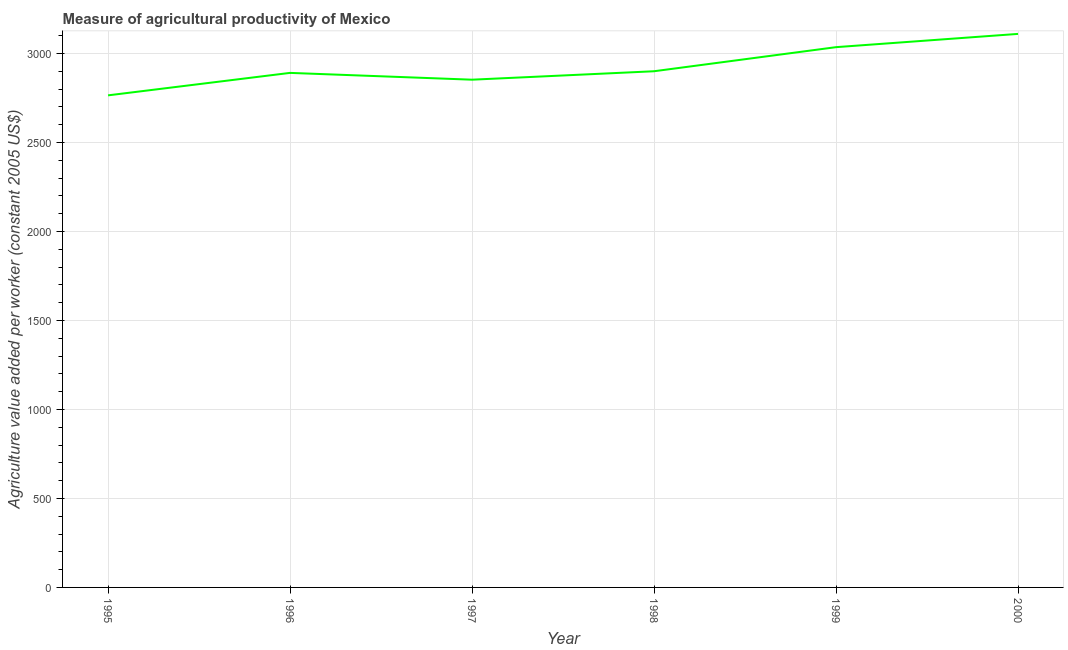What is the agriculture value added per worker in 1996?
Offer a very short reply. 2891.52. Across all years, what is the maximum agriculture value added per worker?
Ensure brevity in your answer.  3110.61. Across all years, what is the minimum agriculture value added per worker?
Provide a succinct answer. 2765.24. In which year was the agriculture value added per worker maximum?
Keep it short and to the point. 2000. In which year was the agriculture value added per worker minimum?
Provide a short and direct response. 1995. What is the sum of the agriculture value added per worker?
Provide a succinct answer. 1.76e+04. What is the difference between the agriculture value added per worker in 1997 and 2000?
Give a very brief answer. -257.34. What is the average agriculture value added per worker per year?
Make the answer very short. 2926.24. What is the median agriculture value added per worker?
Ensure brevity in your answer.  2896.13. In how many years, is the agriculture value added per worker greater than 2400 US$?
Keep it short and to the point. 6. What is the ratio of the agriculture value added per worker in 1995 to that in 1998?
Offer a terse response. 0.95. Is the agriculture value added per worker in 1999 less than that in 2000?
Provide a short and direct response. Yes. Is the difference between the agriculture value added per worker in 1998 and 1999 greater than the difference between any two years?
Make the answer very short. No. What is the difference between the highest and the second highest agriculture value added per worker?
Ensure brevity in your answer.  74.53. Is the sum of the agriculture value added per worker in 1995 and 1997 greater than the maximum agriculture value added per worker across all years?
Make the answer very short. Yes. What is the difference between the highest and the lowest agriculture value added per worker?
Your response must be concise. 345.37. In how many years, is the agriculture value added per worker greater than the average agriculture value added per worker taken over all years?
Offer a very short reply. 2. How many lines are there?
Your response must be concise. 1. Does the graph contain any zero values?
Keep it short and to the point. No. What is the title of the graph?
Provide a succinct answer. Measure of agricultural productivity of Mexico. What is the label or title of the X-axis?
Make the answer very short. Year. What is the label or title of the Y-axis?
Offer a very short reply. Agriculture value added per worker (constant 2005 US$). What is the Agriculture value added per worker (constant 2005 US$) of 1995?
Give a very brief answer. 2765.24. What is the Agriculture value added per worker (constant 2005 US$) of 1996?
Provide a short and direct response. 2891.52. What is the Agriculture value added per worker (constant 2005 US$) in 1997?
Your answer should be compact. 2853.27. What is the Agriculture value added per worker (constant 2005 US$) in 1998?
Ensure brevity in your answer.  2900.74. What is the Agriculture value added per worker (constant 2005 US$) in 1999?
Your response must be concise. 3036.08. What is the Agriculture value added per worker (constant 2005 US$) of 2000?
Your answer should be very brief. 3110.61. What is the difference between the Agriculture value added per worker (constant 2005 US$) in 1995 and 1996?
Provide a short and direct response. -126.28. What is the difference between the Agriculture value added per worker (constant 2005 US$) in 1995 and 1997?
Provide a succinct answer. -88.03. What is the difference between the Agriculture value added per worker (constant 2005 US$) in 1995 and 1998?
Provide a succinct answer. -135.5. What is the difference between the Agriculture value added per worker (constant 2005 US$) in 1995 and 1999?
Offer a terse response. -270.84. What is the difference between the Agriculture value added per worker (constant 2005 US$) in 1995 and 2000?
Provide a succinct answer. -345.37. What is the difference between the Agriculture value added per worker (constant 2005 US$) in 1996 and 1997?
Ensure brevity in your answer.  38.25. What is the difference between the Agriculture value added per worker (constant 2005 US$) in 1996 and 1998?
Your answer should be compact. -9.22. What is the difference between the Agriculture value added per worker (constant 2005 US$) in 1996 and 1999?
Provide a succinct answer. -144.56. What is the difference between the Agriculture value added per worker (constant 2005 US$) in 1996 and 2000?
Offer a terse response. -219.09. What is the difference between the Agriculture value added per worker (constant 2005 US$) in 1997 and 1998?
Provide a short and direct response. -47.47. What is the difference between the Agriculture value added per worker (constant 2005 US$) in 1997 and 1999?
Offer a very short reply. -182.81. What is the difference between the Agriculture value added per worker (constant 2005 US$) in 1997 and 2000?
Give a very brief answer. -257.34. What is the difference between the Agriculture value added per worker (constant 2005 US$) in 1998 and 1999?
Your answer should be compact. -135.34. What is the difference between the Agriculture value added per worker (constant 2005 US$) in 1998 and 2000?
Make the answer very short. -209.87. What is the difference between the Agriculture value added per worker (constant 2005 US$) in 1999 and 2000?
Give a very brief answer. -74.53. What is the ratio of the Agriculture value added per worker (constant 2005 US$) in 1995 to that in 1996?
Your answer should be very brief. 0.96. What is the ratio of the Agriculture value added per worker (constant 2005 US$) in 1995 to that in 1998?
Your answer should be very brief. 0.95. What is the ratio of the Agriculture value added per worker (constant 2005 US$) in 1995 to that in 1999?
Provide a succinct answer. 0.91. What is the ratio of the Agriculture value added per worker (constant 2005 US$) in 1995 to that in 2000?
Your answer should be compact. 0.89. What is the ratio of the Agriculture value added per worker (constant 2005 US$) in 1996 to that in 1997?
Keep it short and to the point. 1.01. What is the ratio of the Agriculture value added per worker (constant 2005 US$) in 1997 to that in 1999?
Keep it short and to the point. 0.94. What is the ratio of the Agriculture value added per worker (constant 2005 US$) in 1997 to that in 2000?
Your answer should be very brief. 0.92. What is the ratio of the Agriculture value added per worker (constant 2005 US$) in 1998 to that in 1999?
Provide a short and direct response. 0.95. What is the ratio of the Agriculture value added per worker (constant 2005 US$) in 1998 to that in 2000?
Keep it short and to the point. 0.93. 